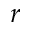Convert formula to latex. <formula><loc_0><loc_0><loc_500><loc_500>r</formula> 